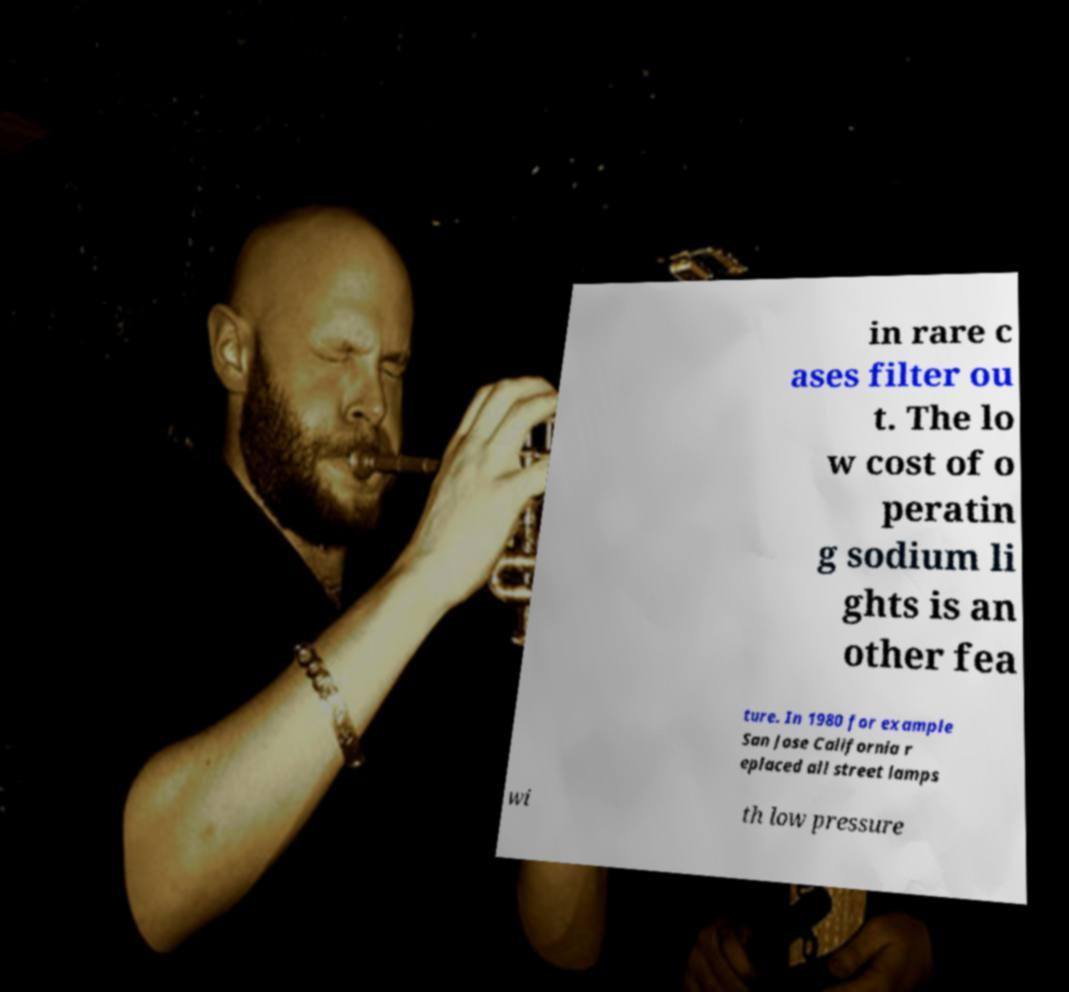Can you read and provide the text displayed in the image?This photo seems to have some interesting text. Can you extract and type it out for me? in rare c ases filter ou t. The lo w cost of o peratin g sodium li ghts is an other fea ture. In 1980 for example San Jose California r eplaced all street lamps wi th low pressure 